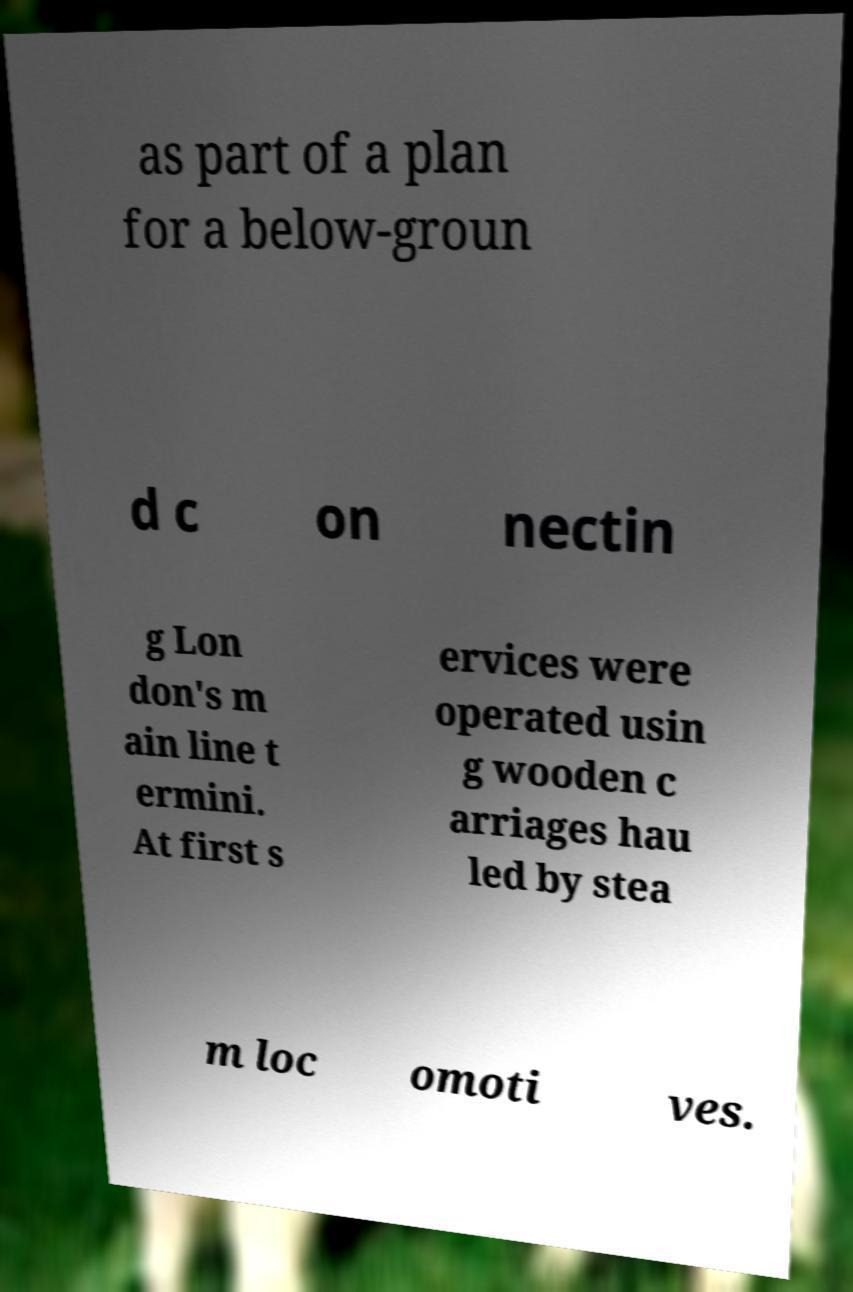What messages or text are displayed in this image? I need them in a readable, typed format. as part of a plan for a below-groun d c on nectin g Lon don's m ain line t ermini. At first s ervices were operated usin g wooden c arriages hau led by stea m loc omoti ves. 